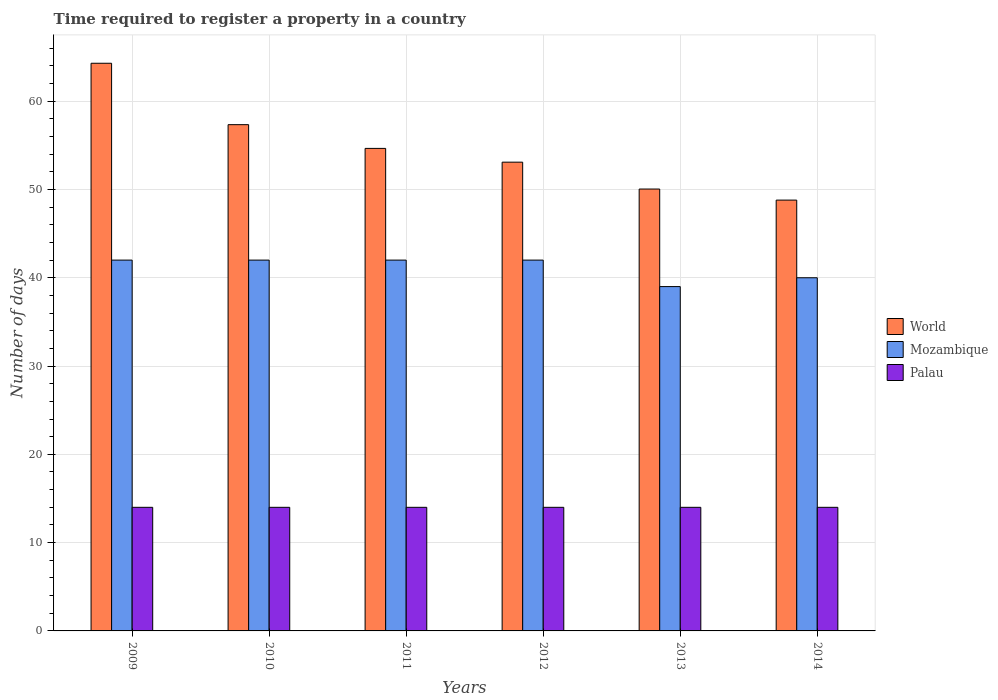How many different coloured bars are there?
Make the answer very short. 3. Are the number of bars per tick equal to the number of legend labels?
Give a very brief answer. Yes. What is the label of the 6th group of bars from the left?
Give a very brief answer. 2014. In how many cases, is the number of bars for a given year not equal to the number of legend labels?
Offer a terse response. 0. What is the number of days required to register a property in Palau in 2010?
Make the answer very short. 14. Across all years, what is the maximum number of days required to register a property in World?
Your answer should be compact. 64.29. Across all years, what is the minimum number of days required to register a property in Mozambique?
Offer a very short reply. 39. In which year was the number of days required to register a property in Palau maximum?
Provide a short and direct response. 2009. In which year was the number of days required to register a property in Palau minimum?
Make the answer very short. 2009. What is the total number of days required to register a property in Mozambique in the graph?
Give a very brief answer. 247. What is the difference between the number of days required to register a property in Mozambique in 2011 and that in 2012?
Give a very brief answer. 0. What is the difference between the number of days required to register a property in World in 2010 and the number of days required to register a property in Palau in 2014?
Your answer should be very brief. 43.34. What is the average number of days required to register a property in Mozambique per year?
Make the answer very short. 41.17. In the year 2014, what is the difference between the number of days required to register a property in Mozambique and number of days required to register a property in Palau?
Offer a terse response. 26. In how many years, is the number of days required to register a property in World greater than 6 days?
Offer a very short reply. 6. Is the number of days required to register a property in Palau in 2012 less than that in 2014?
Give a very brief answer. No. Is the difference between the number of days required to register a property in Mozambique in 2009 and 2013 greater than the difference between the number of days required to register a property in Palau in 2009 and 2013?
Your answer should be compact. Yes. What does the 2nd bar from the right in 2011 represents?
Offer a terse response. Mozambique. What is the difference between two consecutive major ticks on the Y-axis?
Make the answer very short. 10. Are the values on the major ticks of Y-axis written in scientific E-notation?
Keep it short and to the point. No. How many legend labels are there?
Offer a very short reply. 3. What is the title of the graph?
Your answer should be very brief. Time required to register a property in a country. Does "Iraq" appear as one of the legend labels in the graph?
Provide a short and direct response. No. What is the label or title of the X-axis?
Offer a very short reply. Years. What is the label or title of the Y-axis?
Offer a terse response. Number of days. What is the Number of days in World in 2009?
Offer a terse response. 64.29. What is the Number of days in World in 2010?
Provide a short and direct response. 57.34. What is the Number of days in Mozambique in 2010?
Keep it short and to the point. 42. What is the Number of days in World in 2011?
Your answer should be compact. 54.65. What is the Number of days of Palau in 2011?
Give a very brief answer. 14. What is the Number of days in World in 2012?
Offer a terse response. 53.09. What is the Number of days in Palau in 2012?
Your response must be concise. 14. What is the Number of days of World in 2013?
Offer a terse response. 50.05. What is the Number of days of Palau in 2013?
Give a very brief answer. 14. What is the Number of days of World in 2014?
Provide a succinct answer. 48.8. What is the Number of days in Mozambique in 2014?
Keep it short and to the point. 40. What is the Number of days of Palau in 2014?
Ensure brevity in your answer.  14. Across all years, what is the maximum Number of days of World?
Your answer should be compact. 64.29. Across all years, what is the maximum Number of days of Mozambique?
Provide a short and direct response. 42. Across all years, what is the minimum Number of days in World?
Your response must be concise. 48.8. Across all years, what is the minimum Number of days in Mozambique?
Provide a succinct answer. 39. What is the total Number of days of World in the graph?
Your answer should be compact. 328.22. What is the total Number of days in Mozambique in the graph?
Offer a very short reply. 247. What is the difference between the Number of days of World in 2009 and that in 2010?
Ensure brevity in your answer.  6.95. What is the difference between the Number of days in Mozambique in 2009 and that in 2010?
Your answer should be very brief. 0. What is the difference between the Number of days in Palau in 2009 and that in 2010?
Ensure brevity in your answer.  0. What is the difference between the Number of days of World in 2009 and that in 2011?
Your answer should be very brief. 9.64. What is the difference between the Number of days of World in 2009 and that in 2012?
Your response must be concise. 11.2. What is the difference between the Number of days of World in 2009 and that in 2013?
Keep it short and to the point. 14.25. What is the difference between the Number of days in Mozambique in 2009 and that in 2013?
Offer a terse response. 3. What is the difference between the Number of days of Palau in 2009 and that in 2013?
Give a very brief answer. 0. What is the difference between the Number of days of World in 2009 and that in 2014?
Make the answer very short. 15.5. What is the difference between the Number of days in Palau in 2009 and that in 2014?
Your response must be concise. 0. What is the difference between the Number of days in World in 2010 and that in 2011?
Offer a terse response. 2.69. What is the difference between the Number of days of Palau in 2010 and that in 2011?
Keep it short and to the point. 0. What is the difference between the Number of days in World in 2010 and that in 2012?
Keep it short and to the point. 4.25. What is the difference between the Number of days in World in 2010 and that in 2013?
Make the answer very short. 7.29. What is the difference between the Number of days of World in 2010 and that in 2014?
Ensure brevity in your answer.  8.55. What is the difference between the Number of days of Palau in 2010 and that in 2014?
Your answer should be very brief. 0. What is the difference between the Number of days of World in 2011 and that in 2012?
Offer a terse response. 1.56. What is the difference between the Number of days in Palau in 2011 and that in 2012?
Your answer should be compact. 0. What is the difference between the Number of days in World in 2011 and that in 2013?
Your answer should be compact. 4.6. What is the difference between the Number of days of Palau in 2011 and that in 2013?
Provide a short and direct response. 0. What is the difference between the Number of days of World in 2011 and that in 2014?
Offer a very short reply. 5.86. What is the difference between the Number of days in Palau in 2011 and that in 2014?
Keep it short and to the point. 0. What is the difference between the Number of days in World in 2012 and that in 2013?
Provide a short and direct response. 3.04. What is the difference between the Number of days of Mozambique in 2012 and that in 2013?
Give a very brief answer. 3. What is the difference between the Number of days in Palau in 2012 and that in 2013?
Keep it short and to the point. 0. What is the difference between the Number of days of World in 2012 and that in 2014?
Your response must be concise. 4.3. What is the difference between the Number of days of Mozambique in 2012 and that in 2014?
Give a very brief answer. 2. What is the difference between the Number of days in Palau in 2012 and that in 2014?
Provide a succinct answer. 0. What is the difference between the Number of days of World in 2013 and that in 2014?
Ensure brevity in your answer.  1.25. What is the difference between the Number of days of Palau in 2013 and that in 2014?
Make the answer very short. 0. What is the difference between the Number of days of World in 2009 and the Number of days of Mozambique in 2010?
Ensure brevity in your answer.  22.29. What is the difference between the Number of days in World in 2009 and the Number of days in Palau in 2010?
Make the answer very short. 50.29. What is the difference between the Number of days in World in 2009 and the Number of days in Mozambique in 2011?
Give a very brief answer. 22.29. What is the difference between the Number of days of World in 2009 and the Number of days of Palau in 2011?
Offer a terse response. 50.29. What is the difference between the Number of days of World in 2009 and the Number of days of Mozambique in 2012?
Your answer should be compact. 22.29. What is the difference between the Number of days in World in 2009 and the Number of days in Palau in 2012?
Your answer should be very brief. 50.29. What is the difference between the Number of days in World in 2009 and the Number of days in Mozambique in 2013?
Keep it short and to the point. 25.29. What is the difference between the Number of days in World in 2009 and the Number of days in Palau in 2013?
Your response must be concise. 50.29. What is the difference between the Number of days in World in 2009 and the Number of days in Mozambique in 2014?
Your answer should be compact. 24.29. What is the difference between the Number of days in World in 2009 and the Number of days in Palau in 2014?
Provide a short and direct response. 50.29. What is the difference between the Number of days of Mozambique in 2009 and the Number of days of Palau in 2014?
Offer a very short reply. 28. What is the difference between the Number of days of World in 2010 and the Number of days of Mozambique in 2011?
Provide a succinct answer. 15.34. What is the difference between the Number of days of World in 2010 and the Number of days of Palau in 2011?
Your answer should be compact. 43.34. What is the difference between the Number of days in Mozambique in 2010 and the Number of days in Palau in 2011?
Your response must be concise. 28. What is the difference between the Number of days of World in 2010 and the Number of days of Mozambique in 2012?
Provide a short and direct response. 15.34. What is the difference between the Number of days in World in 2010 and the Number of days in Palau in 2012?
Offer a terse response. 43.34. What is the difference between the Number of days in World in 2010 and the Number of days in Mozambique in 2013?
Keep it short and to the point. 18.34. What is the difference between the Number of days of World in 2010 and the Number of days of Palau in 2013?
Make the answer very short. 43.34. What is the difference between the Number of days of Mozambique in 2010 and the Number of days of Palau in 2013?
Offer a very short reply. 28. What is the difference between the Number of days in World in 2010 and the Number of days in Mozambique in 2014?
Your answer should be very brief. 17.34. What is the difference between the Number of days in World in 2010 and the Number of days in Palau in 2014?
Offer a terse response. 43.34. What is the difference between the Number of days of Mozambique in 2010 and the Number of days of Palau in 2014?
Provide a short and direct response. 28. What is the difference between the Number of days of World in 2011 and the Number of days of Mozambique in 2012?
Your answer should be very brief. 12.65. What is the difference between the Number of days in World in 2011 and the Number of days in Palau in 2012?
Your answer should be compact. 40.65. What is the difference between the Number of days in World in 2011 and the Number of days in Mozambique in 2013?
Make the answer very short. 15.65. What is the difference between the Number of days in World in 2011 and the Number of days in Palau in 2013?
Ensure brevity in your answer.  40.65. What is the difference between the Number of days in Mozambique in 2011 and the Number of days in Palau in 2013?
Your response must be concise. 28. What is the difference between the Number of days of World in 2011 and the Number of days of Mozambique in 2014?
Ensure brevity in your answer.  14.65. What is the difference between the Number of days of World in 2011 and the Number of days of Palau in 2014?
Give a very brief answer. 40.65. What is the difference between the Number of days in Mozambique in 2011 and the Number of days in Palau in 2014?
Ensure brevity in your answer.  28. What is the difference between the Number of days in World in 2012 and the Number of days in Mozambique in 2013?
Offer a terse response. 14.09. What is the difference between the Number of days in World in 2012 and the Number of days in Palau in 2013?
Your answer should be very brief. 39.09. What is the difference between the Number of days in World in 2012 and the Number of days in Mozambique in 2014?
Provide a succinct answer. 13.09. What is the difference between the Number of days of World in 2012 and the Number of days of Palau in 2014?
Offer a very short reply. 39.09. What is the difference between the Number of days in World in 2013 and the Number of days in Mozambique in 2014?
Provide a succinct answer. 10.05. What is the difference between the Number of days of World in 2013 and the Number of days of Palau in 2014?
Make the answer very short. 36.05. What is the average Number of days of World per year?
Provide a succinct answer. 54.7. What is the average Number of days in Mozambique per year?
Ensure brevity in your answer.  41.17. What is the average Number of days in Palau per year?
Keep it short and to the point. 14. In the year 2009, what is the difference between the Number of days of World and Number of days of Mozambique?
Ensure brevity in your answer.  22.29. In the year 2009, what is the difference between the Number of days in World and Number of days in Palau?
Offer a terse response. 50.29. In the year 2010, what is the difference between the Number of days in World and Number of days in Mozambique?
Provide a short and direct response. 15.34. In the year 2010, what is the difference between the Number of days in World and Number of days in Palau?
Keep it short and to the point. 43.34. In the year 2011, what is the difference between the Number of days of World and Number of days of Mozambique?
Your response must be concise. 12.65. In the year 2011, what is the difference between the Number of days in World and Number of days in Palau?
Offer a very short reply. 40.65. In the year 2012, what is the difference between the Number of days in World and Number of days in Mozambique?
Keep it short and to the point. 11.09. In the year 2012, what is the difference between the Number of days of World and Number of days of Palau?
Ensure brevity in your answer.  39.09. In the year 2012, what is the difference between the Number of days of Mozambique and Number of days of Palau?
Your answer should be compact. 28. In the year 2013, what is the difference between the Number of days in World and Number of days in Mozambique?
Your answer should be very brief. 11.05. In the year 2013, what is the difference between the Number of days in World and Number of days in Palau?
Ensure brevity in your answer.  36.05. In the year 2014, what is the difference between the Number of days in World and Number of days in Mozambique?
Offer a very short reply. 8.8. In the year 2014, what is the difference between the Number of days in World and Number of days in Palau?
Your answer should be very brief. 34.8. In the year 2014, what is the difference between the Number of days in Mozambique and Number of days in Palau?
Your response must be concise. 26. What is the ratio of the Number of days in World in 2009 to that in 2010?
Provide a succinct answer. 1.12. What is the ratio of the Number of days in World in 2009 to that in 2011?
Your answer should be very brief. 1.18. What is the ratio of the Number of days in Mozambique in 2009 to that in 2011?
Ensure brevity in your answer.  1. What is the ratio of the Number of days of Palau in 2009 to that in 2011?
Your answer should be compact. 1. What is the ratio of the Number of days in World in 2009 to that in 2012?
Give a very brief answer. 1.21. What is the ratio of the Number of days of Mozambique in 2009 to that in 2012?
Your answer should be very brief. 1. What is the ratio of the Number of days in Palau in 2009 to that in 2012?
Keep it short and to the point. 1. What is the ratio of the Number of days of World in 2009 to that in 2013?
Provide a succinct answer. 1.28. What is the ratio of the Number of days of World in 2009 to that in 2014?
Your answer should be very brief. 1.32. What is the ratio of the Number of days of Mozambique in 2009 to that in 2014?
Your answer should be very brief. 1.05. What is the ratio of the Number of days of Palau in 2009 to that in 2014?
Provide a short and direct response. 1. What is the ratio of the Number of days in World in 2010 to that in 2011?
Make the answer very short. 1.05. What is the ratio of the Number of days in Mozambique in 2010 to that in 2011?
Give a very brief answer. 1. What is the ratio of the Number of days in World in 2010 to that in 2012?
Your answer should be very brief. 1.08. What is the ratio of the Number of days of Palau in 2010 to that in 2012?
Offer a terse response. 1. What is the ratio of the Number of days of World in 2010 to that in 2013?
Ensure brevity in your answer.  1.15. What is the ratio of the Number of days of Mozambique in 2010 to that in 2013?
Provide a short and direct response. 1.08. What is the ratio of the Number of days of World in 2010 to that in 2014?
Your answer should be very brief. 1.18. What is the ratio of the Number of days in Palau in 2010 to that in 2014?
Provide a succinct answer. 1. What is the ratio of the Number of days of World in 2011 to that in 2012?
Make the answer very short. 1.03. What is the ratio of the Number of days in Mozambique in 2011 to that in 2012?
Keep it short and to the point. 1. What is the ratio of the Number of days in Palau in 2011 to that in 2012?
Offer a terse response. 1. What is the ratio of the Number of days of World in 2011 to that in 2013?
Give a very brief answer. 1.09. What is the ratio of the Number of days of Mozambique in 2011 to that in 2013?
Your response must be concise. 1.08. What is the ratio of the Number of days of Palau in 2011 to that in 2013?
Give a very brief answer. 1. What is the ratio of the Number of days in World in 2011 to that in 2014?
Make the answer very short. 1.12. What is the ratio of the Number of days in Mozambique in 2011 to that in 2014?
Provide a short and direct response. 1.05. What is the ratio of the Number of days in Palau in 2011 to that in 2014?
Offer a very short reply. 1. What is the ratio of the Number of days in World in 2012 to that in 2013?
Your response must be concise. 1.06. What is the ratio of the Number of days in World in 2012 to that in 2014?
Your answer should be very brief. 1.09. What is the ratio of the Number of days of World in 2013 to that in 2014?
Provide a succinct answer. 1.03. What is the difference between the highest and the second highest Number of days of World?
Provide a succinct answer. 6.95. What is the difference between the highest and the second highest Number of days of Mozambique?
Provide a succinct answer. 0. What is the difference between the highest and the second highest Number of days in Palau?
Make the answer very short. 0. What is the difference between the highest and the lowest Number of days of World?
Your response must be concise. 15.5. What is the difference between the highest and the lowest Number of days of Mozambique?
Offer a very short reply. 3. What is the difference between the highest and the lowest Number of days in Palau?
Your answer should be compact. 0. 